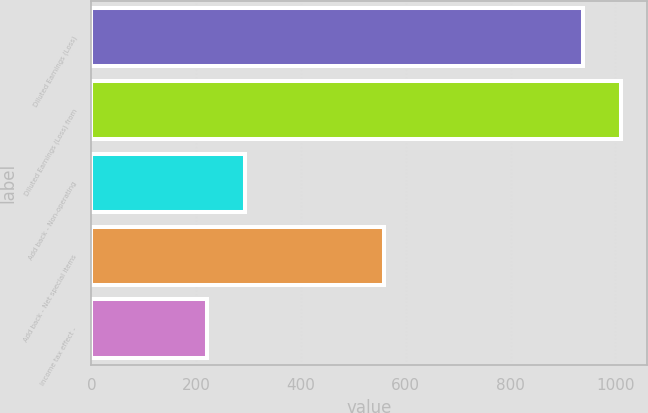Convert chart. <chart><loc_0><loc_0><loc_500><loc_500><bar_chart><fcel>Diluted Earnings (Loss)<fcel>Diluted Earnings (Loss) from<fcel>Add back - Non-operating<fcel>Add back - Net special items<fcel>Income tax effect -<nl><fcel>938<fcel>1009.7<fcel>292.7<fcel>559<fcel>221<nl></chart> 